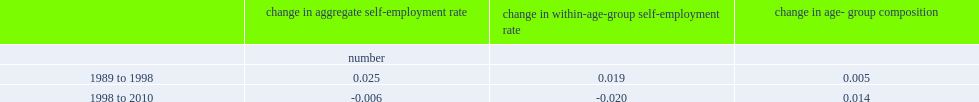What's the percent of the aggregate self-employment rate from 1989 to 1998? 0.025. What's the percent of the within-age-group component from 1989 to 1998? 0.019. What's the percent of the share of total employment to older age groups from 1989 to 1998? 0.005. How much did the within-age-group component declined from 1998 to 2010? 0.02. What's the percent changed of the aggregate self-employment rate in the 1989-to-1998 period? 0.025. What's the percent changed of the aggregate self-employment rate after 1998? 0.014. What's the percent changed of the aggregate self-employment rate in the 1989-to-1998 period in age-group composition? 0.005. 